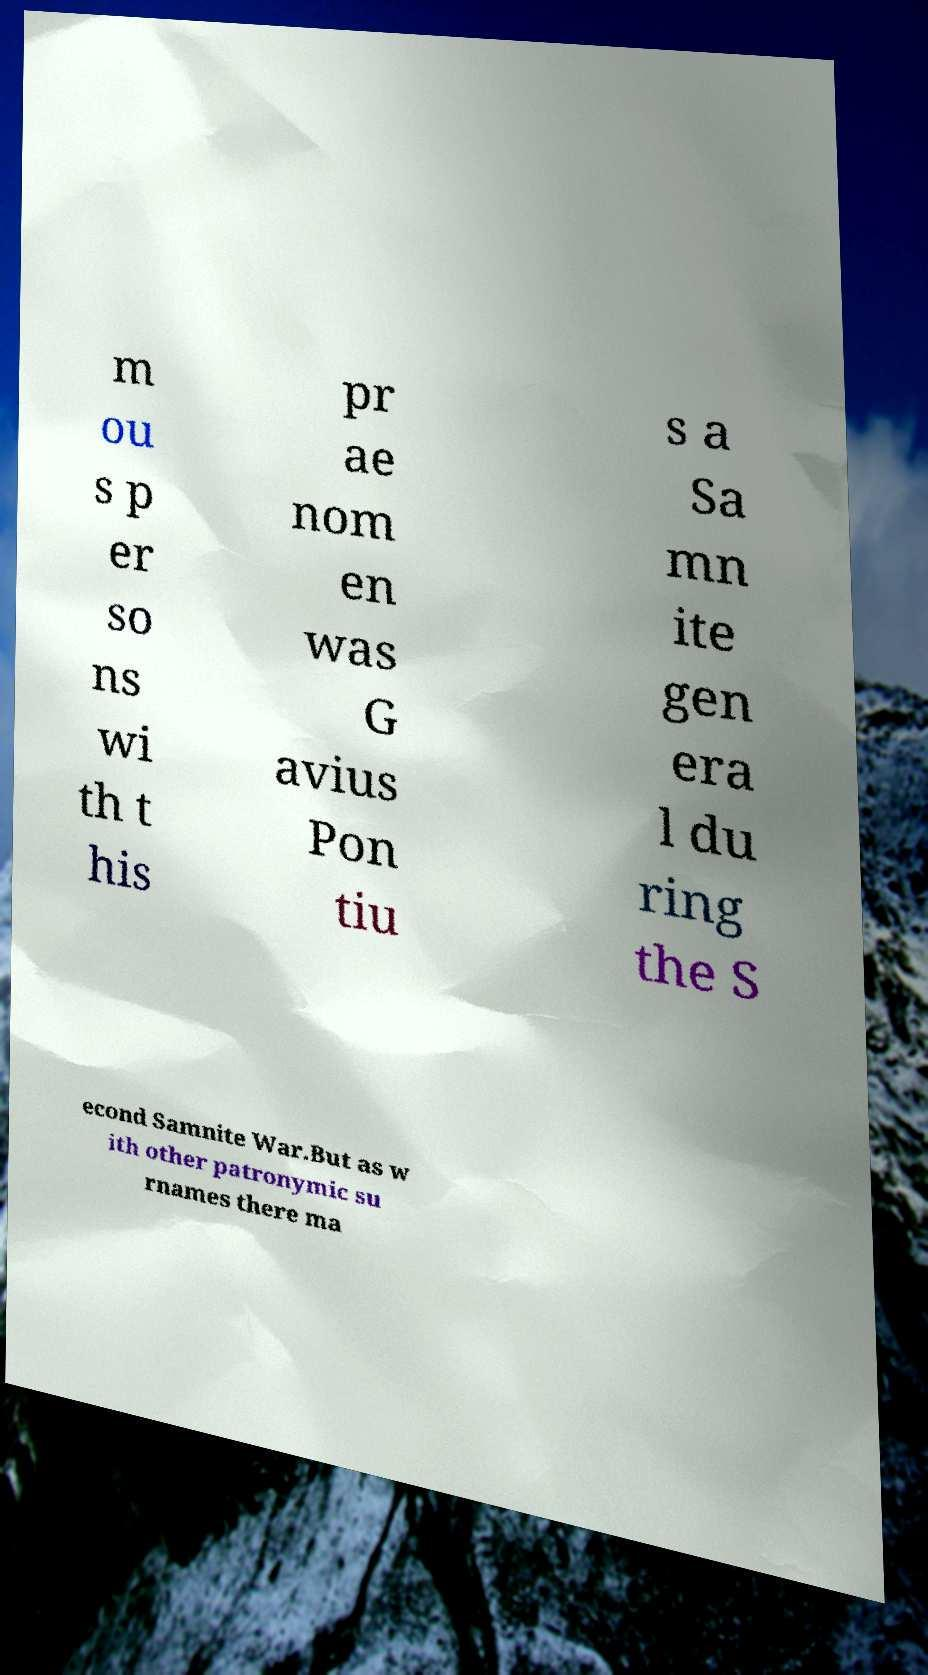Please read and relay the text visible in this image. What does it say? m ou s p er so ns wi th t his pr ae nom en was G avius Pon tiu s a Sa mn ite gen era l du ring the S econd Samnite War.But as w ith other patronymic su rnames there ma 